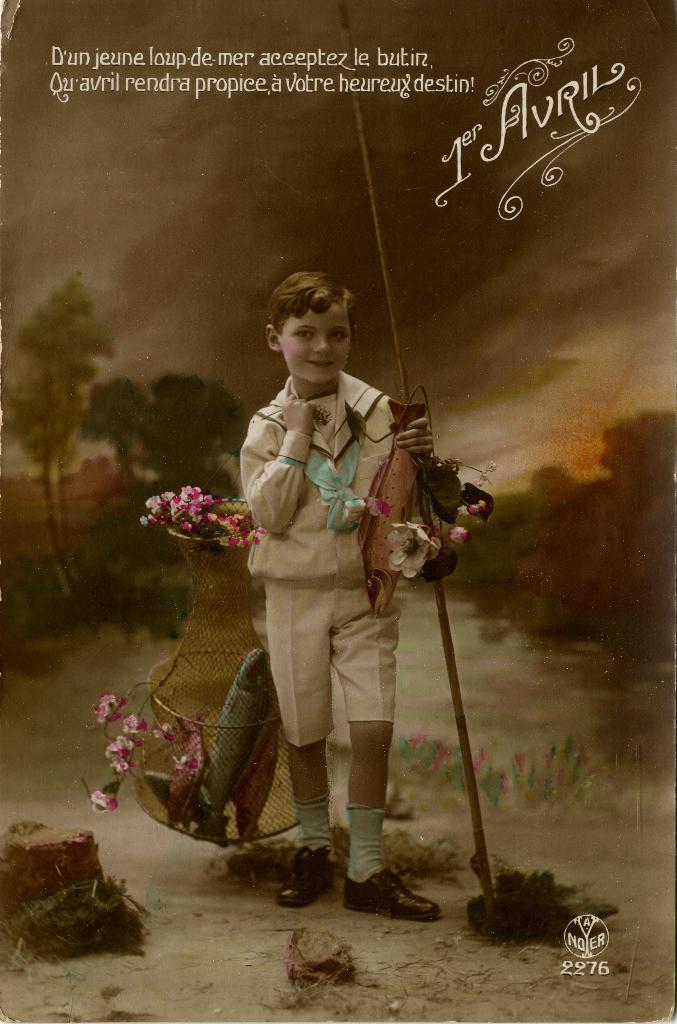Describe this image in one or two sentences. In this image I can see there is a poster and a text written on it. And there is a person standing and holding a fish and a stick. And he is carrying a flower pot. And at the back there are trees. 